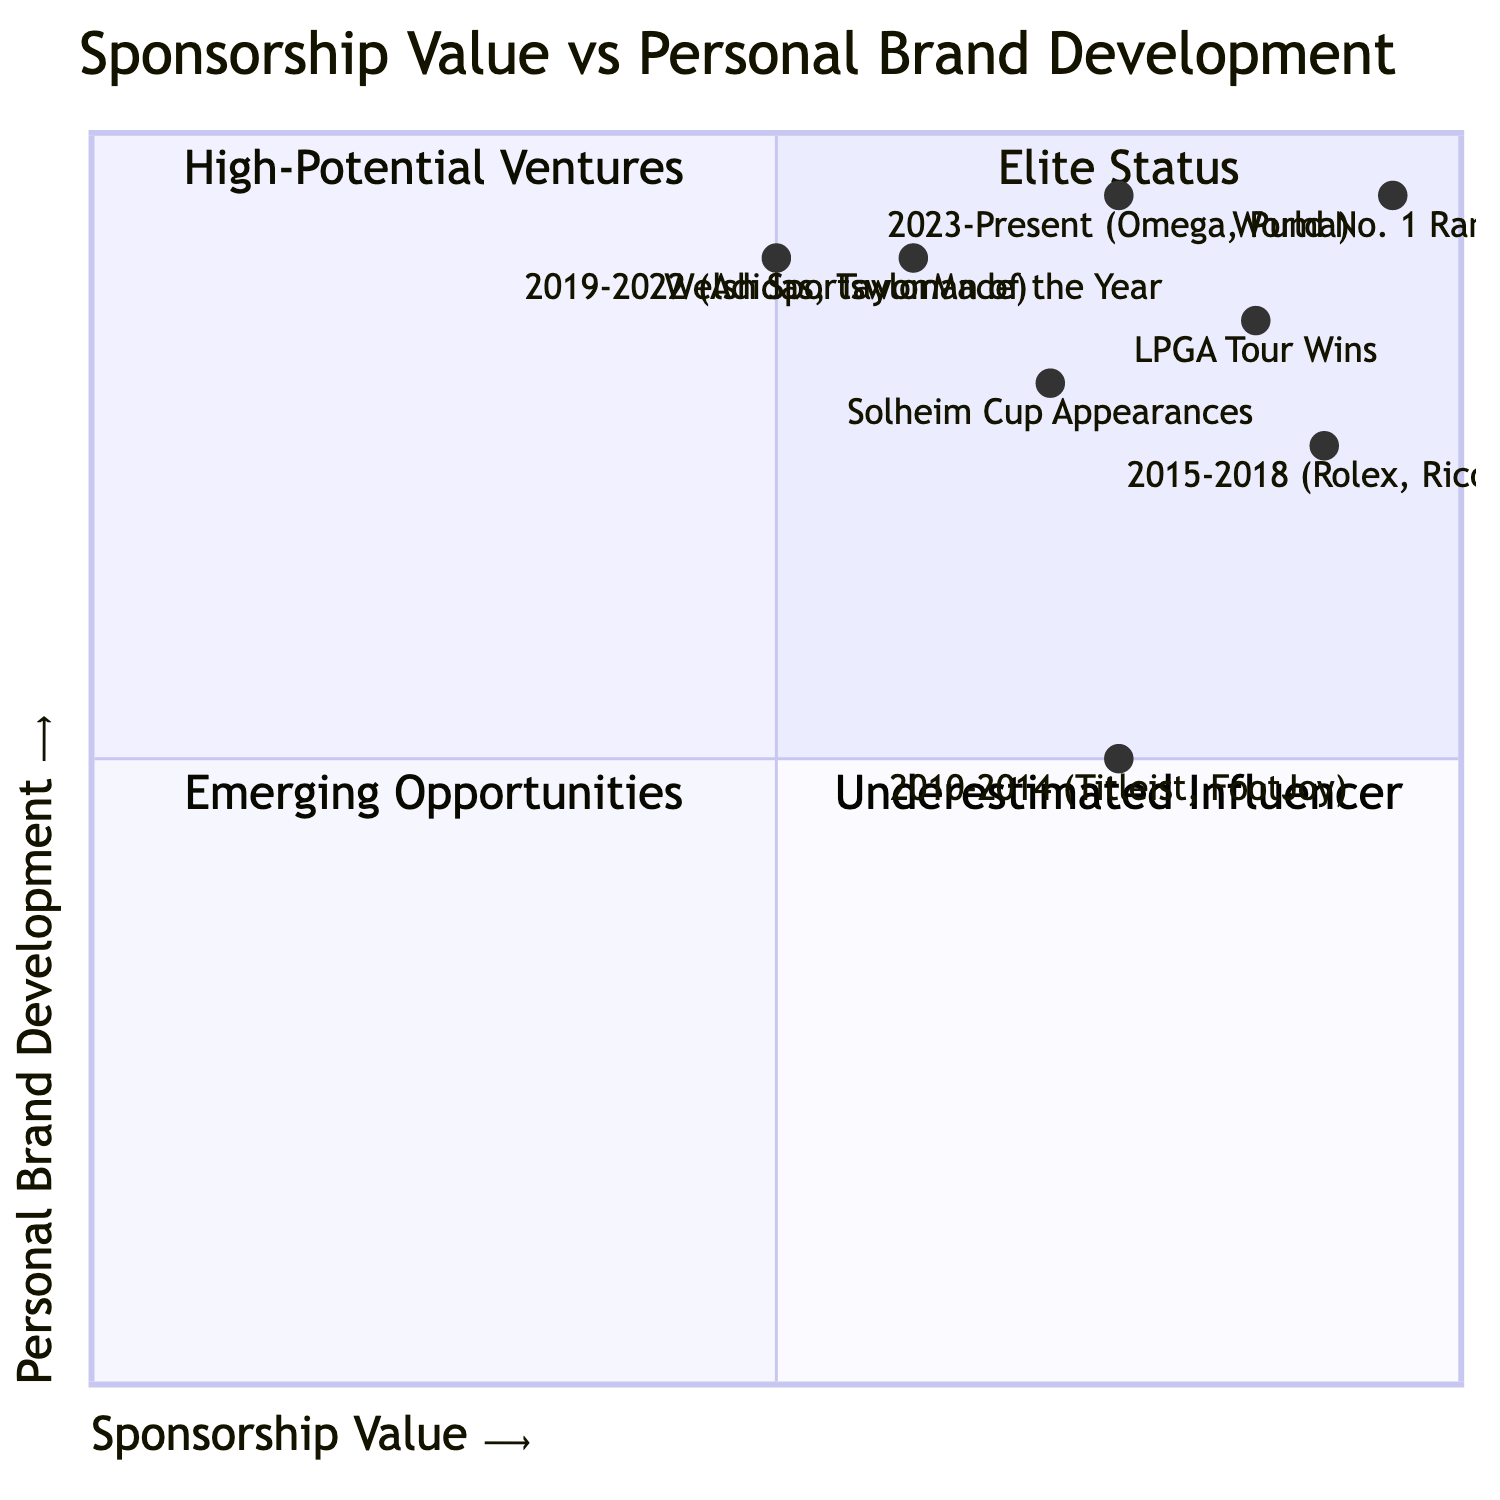What period has the highest sponsorship value? The diagram shows the periods along the x-axis representing sponsorship value. The highest value indicated is during the period 2015-2018, which is labeled as "Very High."
Answer: 2015-2018 Which sponsors were associated with the "High-Potential Ventures" quadrant? To determine the sponsors in the "High-Potential Ventures" quadrant, we look at the point associated with the period 2010-2014, which has a sponsorship value of High and personal brand development of Moderate. The sponsors listed are Titleist and FootJoy.
Answer: Titleist, FootJoy What is the personal brand development level in the "Underestimated Influencer" quadrant? The "Underestimated Influencer" quadrant corresponds to low sponsorship value and high personal brand development. Referring to the data, during 2019-2022, the personal brand development level is "Very High."
Answer: Very High How many major events are highlighted in the diagram? The data lists two major events: LPGA Tour Wins and Solheim Cup Appearances. Counting these events gives a total of two.
Answer: 2 Which quadrant does the period 2023-Present fall into? The point for the period 2023-Present is plotted with a high sponsorship value and very high personal brand development, placing it in the "Elite Status" quadrant.
Answer: Elite Status What was the sponsorship value in 2019-2022? According to the diagram, the sponsorship value for the period 2019-2022 is listed as "Moderate."
Answer: Moderate Which key sponsor is associated with the period that has the title for "Welsh Sportswoman of the Year"? To find this sponsor, we refer to the period where this title is mentioned. The period corresponding is 2010-2014, and the key sponsors during this time were Titleist and FootJoy.
Answer: Titleist, FootJoy Which career highlight has the highest values in both sponsorship and brand development? The World No. 1 Ranking is labeled on the diagram with the values [0.95, 0.95], indicating both high sponsorship value and personal brand development compared to the other highlights.
Answer: World No. 1 Ranking 